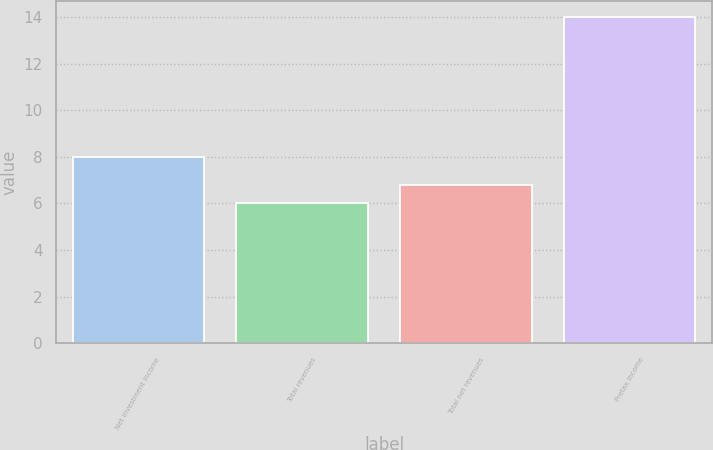Convert chart. <chart><loc_0><loc_0><loc_500><loc_500><bar_chart><fcel>Net investment income<fcel>Total revenues<fcel>Total net revenues<fcel>Pretax income<nl><fcel>8<fcel>6<fcel>6.8<fcel>14<nl></chart> 